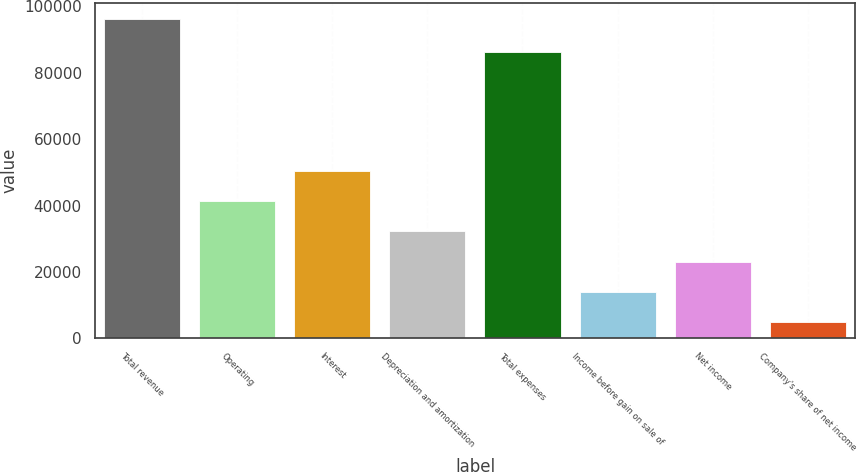Convert chart. <chart><loc_0><loc_0><loc_500><loc_500><bar_chart><fcel>Total revenue<fcel>Operating<fcel>Interest<fcel>Depreciation and amortization<fcel>Total expenses<fcel>Income before gain on sale of<fcel>Net income<fcel>Company's share of net income<nl><fcel>96189<fcel>41373<fcel>50509<fcel>32237<fcel>86177<fcel>13965<fcel>23101<fcel>4829<nl></chart> 